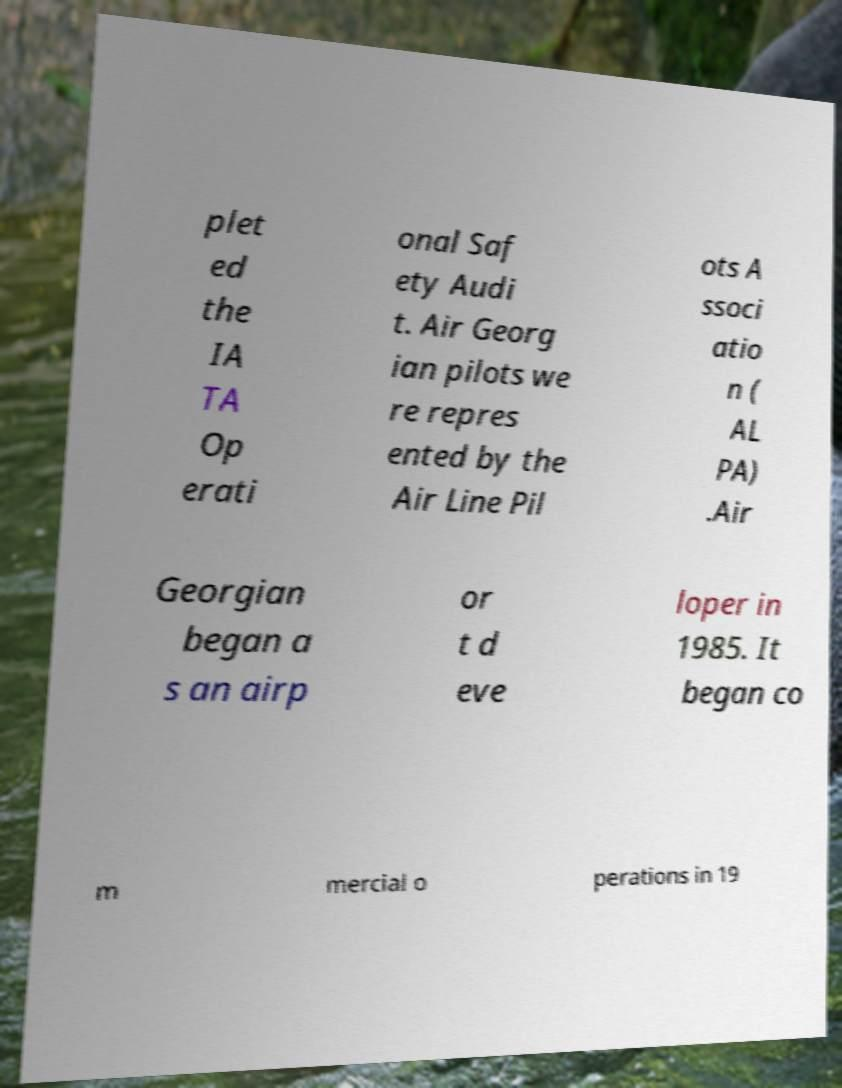Can you read and provide the text displayed in the image?This photo seems to have some interesting text. Can you extract and type it out for me? plet ed the IA TA Op erati onal Saf ety Audi t. Air Georg ian pilots we re repres ented by the Air Line Pil ots A ssoci atio n ( AL PA) .Air Georgian began a s an airp or t d eve loper in 1985. It began co m mercial o perations in 19 